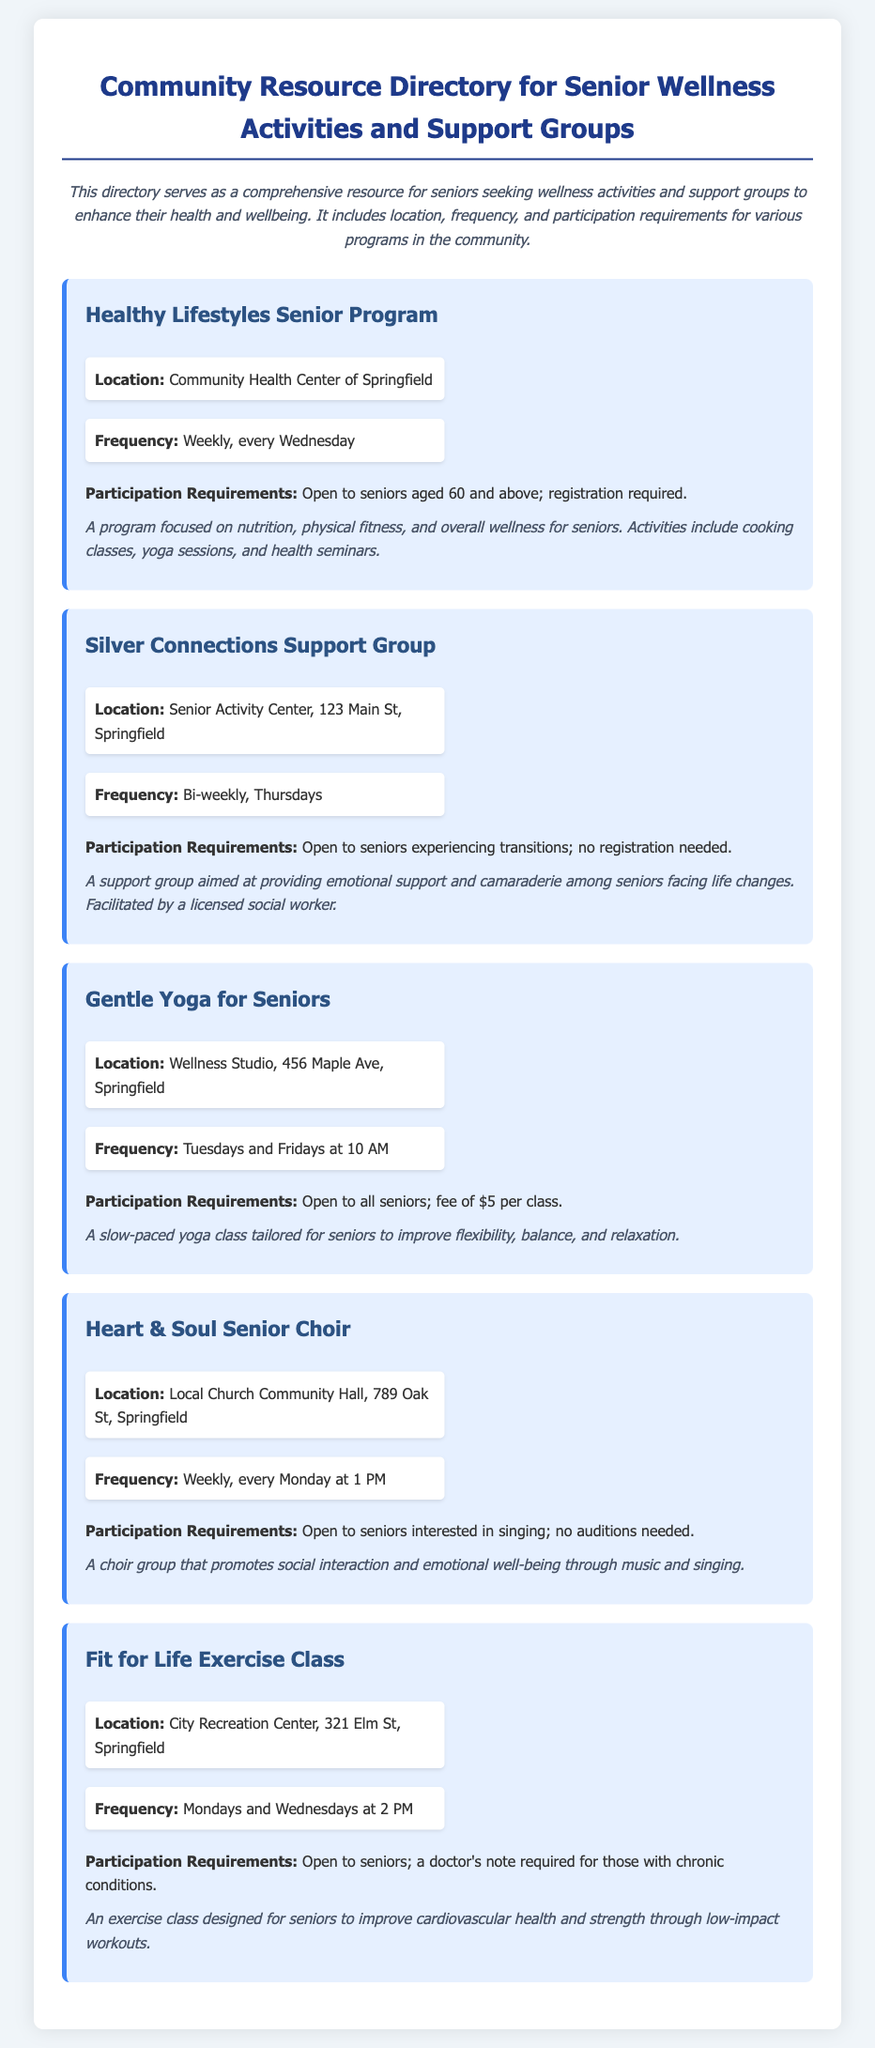What is the location of the Healthy Lifestyles Senior Program? The location is specified in the document as the Community Health Center of Springfield.
Answer: Community Health Center of Springfield How often does the Silver Connections Support Group meet? The frequency is mentioned as bi-weekly on Thursdays in the document.
Answer: Bi-weekly, Thursdays What is the participation requirement for Gentle Yoga for Seniors? The document states that it is open to all seniors and has a fee of $5 per class.
Answer: Open to all seniors; fee of $5 per class When does the Heart & Soul Senior Choir meet? The document specifies that the choir meets every Monday at 1 PM.
Answer: Every Monday at 1 PM What is the focus of the Fit for Life Exercise Class? The class is designed to improve cardiovascular health and strength through low-impact workouts, as stated in the document.
Answer: Improve cardiovascular health and strength Which program requires registration? The document indicates that registration is required for the Healthy Lifestyles Senior Program.
Answer: Healthy Lifestyles Senior Program Why is the Silver Connections Support Group unique? This group is noted for providing emotional support and camaraderie among seniors facing life changes, as highlighted in the document.
Answer: Emotional support and camaraderie What type of activities does the Healthy Lifestyles Senior Program include? The document lists cooking classes, yoga sessions, and health seminars as activities in the program.
Answer: Cooking classes, yoga sessions, and health seminars Which program has a location on 456 Maple Ave? The document specifies that Gentle Yoga for Seniors is located at this address.
Answer: Gentle Yoga for Seniors 